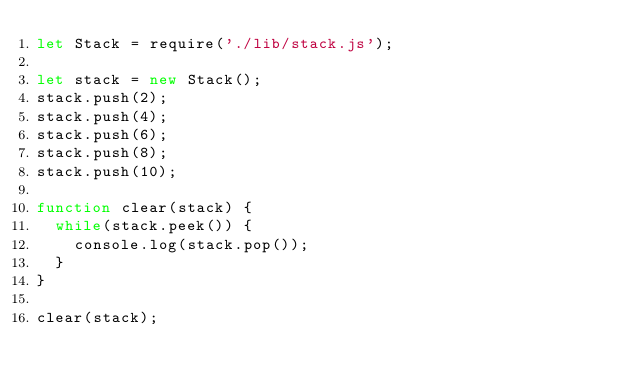<code> <loc_0><loc_0><loc_500><loc_500><_JavaScript_>let Stack = require('./lib/stack.js');

let stack = new Stack();
stack.push(2);
stack.push(4);
stack.push(6);
stack.push(8);
stack.push(10);

function clear(stack) {
  while(stack.peek()) { 
    console.log(stack.pop());
  }
}

clear(stack);
</code> 